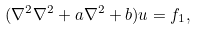Convert formula to latex. <formula><loc_0><loc_0><loc_500><loc_500>( \nabla ^ { 2 } \nabla ^ { 2 } + a \nabla ^ { 2 } + b ) u = f _ { 1 } ,</formula> 